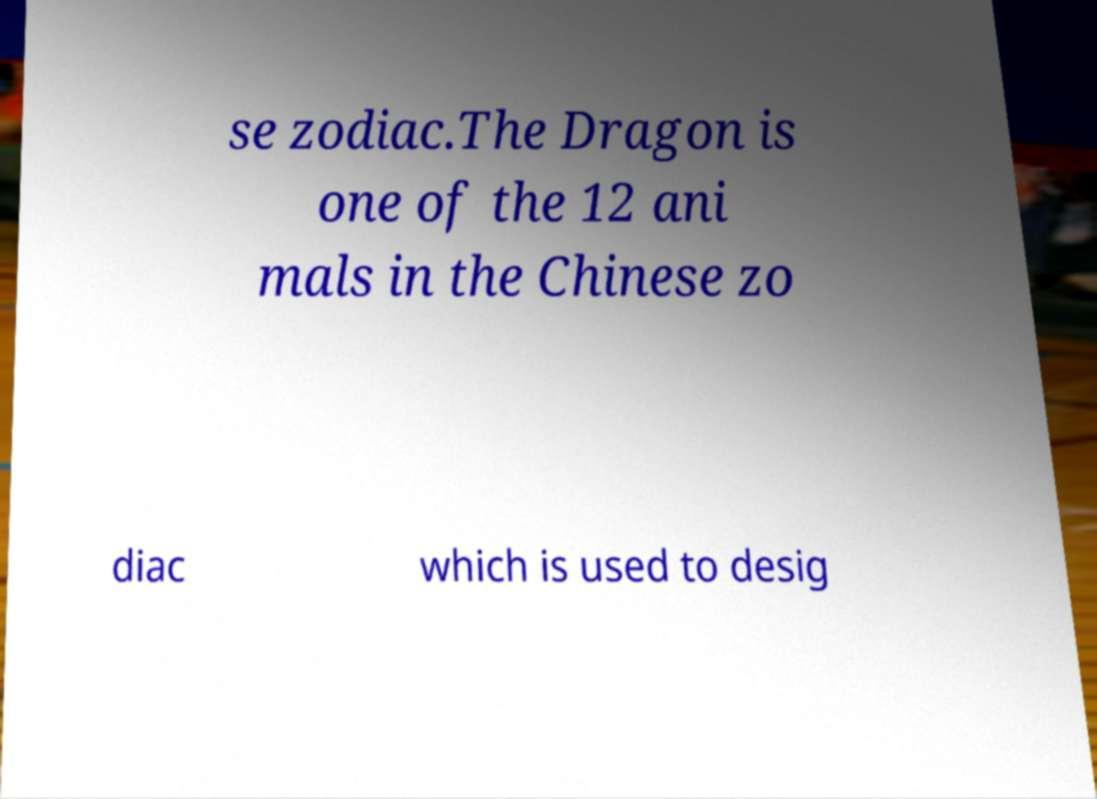Can you accurately transcribe the text from the provided image for me? se zodiac.The Dragon is one of the 12 ani mals in the Chinese zo diac which is used to desig 